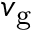Convert formula to latex. <formula><loc_0><loc_0><loc_500><loc_500>v _ { g }</formula> 